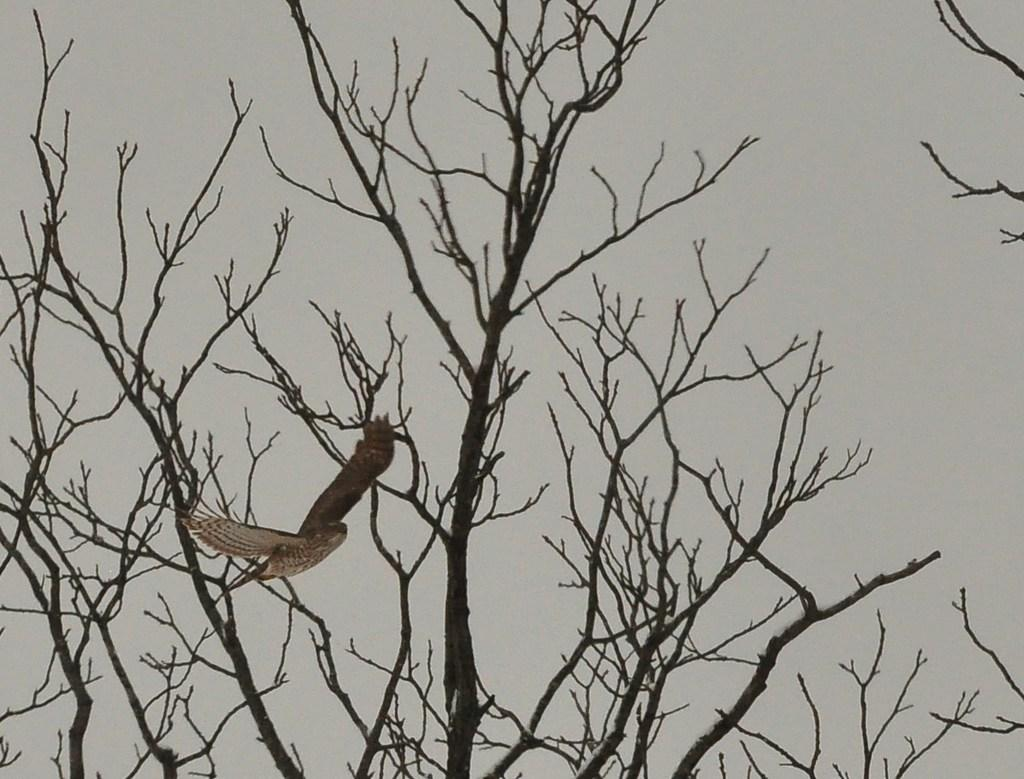What type of animal can be seen in the image? There is a bird in the image. Can you describe the bird's coloring? The bird has white and brown colors. What can be seen in the background of the image? There are dried trees in the image. What is the color of the sky in the background? The sky in the background is white. Where is the cobweb located in the image? There is no cobweb present in the image. What type of town can be seen in the background of the image? There is no town visible in the image; it features a bird, dried trees, and a white sky. 